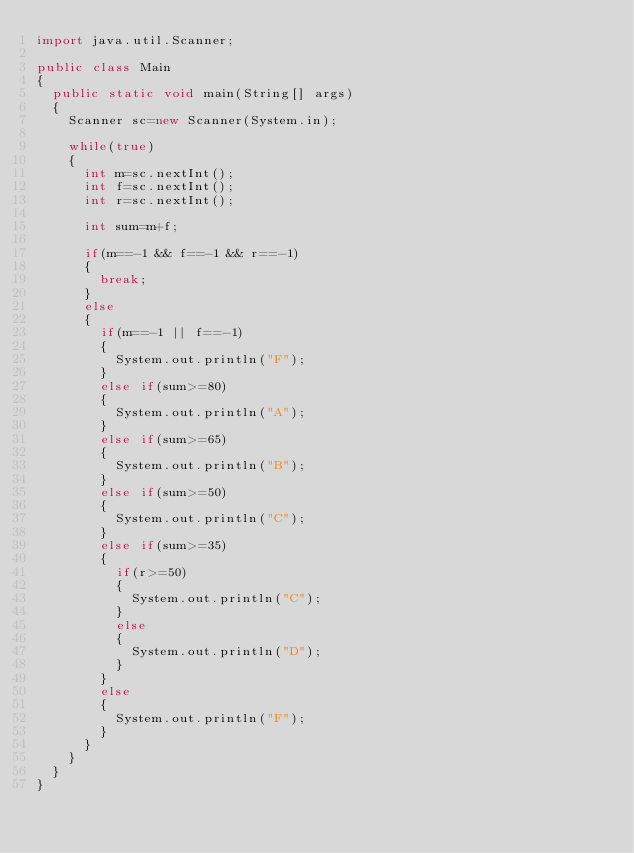<code> <loc_0><loc_0><loc_500><loc_500><_Java_>import java.util.Scanner;

public class Main
{
  public static void main(String[] args)
  {
    Scanner sc=new Scanner(System.in);

    while(true)
    {
      int m=sc.nextInt();
      int f=sc.nextInt();
      int r=sc.nextInt();

      int sum=m+f;

      if(m==-1 && f==-1 && r==-1)
      {
        break;
      }
      else
      {
        if(m==-1 || f==-1)
        {
          System.out.println("F");
        }
        else if(sum>=80)
        {
          System.out.println("A");
        }
        else if(sum>=65)
        {
          System.out.println("B");
        }
        else if(sum>=50)
        {
          System.out.println("C");
        }
        else if(sum>=35)
        {
          if(r>=50)
          {
            System.out.println("C");
          }
          else
          {
            System.out.println("D");
          }
        }
        else
        {
          System.out.println("F");
        }
      }
    }
  }
}</code> 